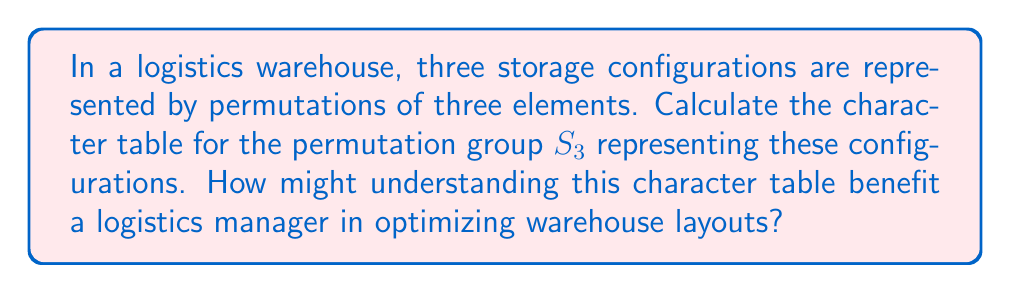Could you help me with this problem? Let's approach this step-by-step:

1) First, identify the elements of $S_3$:
   $e = (1)$, $(12)$, $(13)$, $(23)$, $(123)$, $(132)$

2) Determine the conjugacy classes:
   $\{e\}$, $\{(12), (13), (23)\}$, $\{(123), (132)\}$

3) The number of irreducible representations equals the number of conjugacy classes, which is 3.

4) The dimensions of these representations must satisfy:
   $1^2 + 1^2 + 2^2 = 6$ (order of the group)

   So, we have two 1-dimensional representations and one 2-dimensional representation.

5) For the trivial representation, all characters are 1.

6) For the sign representation, even permutations have character 1, odd permutations have -1.

7) For the 2-dimensional representation:
   - $\chi(e) = 2$ (trace of 2x2 identity matrix)
   - $\chi((12)) = 0$ (trace of rotation by 180°)
   - $\chi((123)) = -1$ (trace of rotation by 120°)

8) Construct the character table:

   $$
   \begin{array}{c|ccc}
    S_3 & \{e\} & \{(12),(13),(23)\} & \{(123),(132)\} \\
   \hline
   \chi_1 & 1 & 1 & 1 \\
   \chi_2 & 1 & -1 & 1 \\
   \chi_3 & 2 & 0 & -1
   \end{array}
   $$

9) For a logistics manager, understanding this character table can help in:
   - Identifying symmetries in warehouse configurations
   - Optimizing storage layouts by exploiting these symmetries
   - Developing efficient algorithms for inventory management based on group theory
Answer: $$
\begin{array}{c|ccc}
S_3 & \{e\} & \{(12),(13),(23)\} & \{(123),(132)\} \\
\hline
\chi_1 & 1 & 1 & 1 \\
\chi_2 & 1 & -1 & 1 \\
\chi_3 & 2 & 0 & -1
\end{array}
$$ 